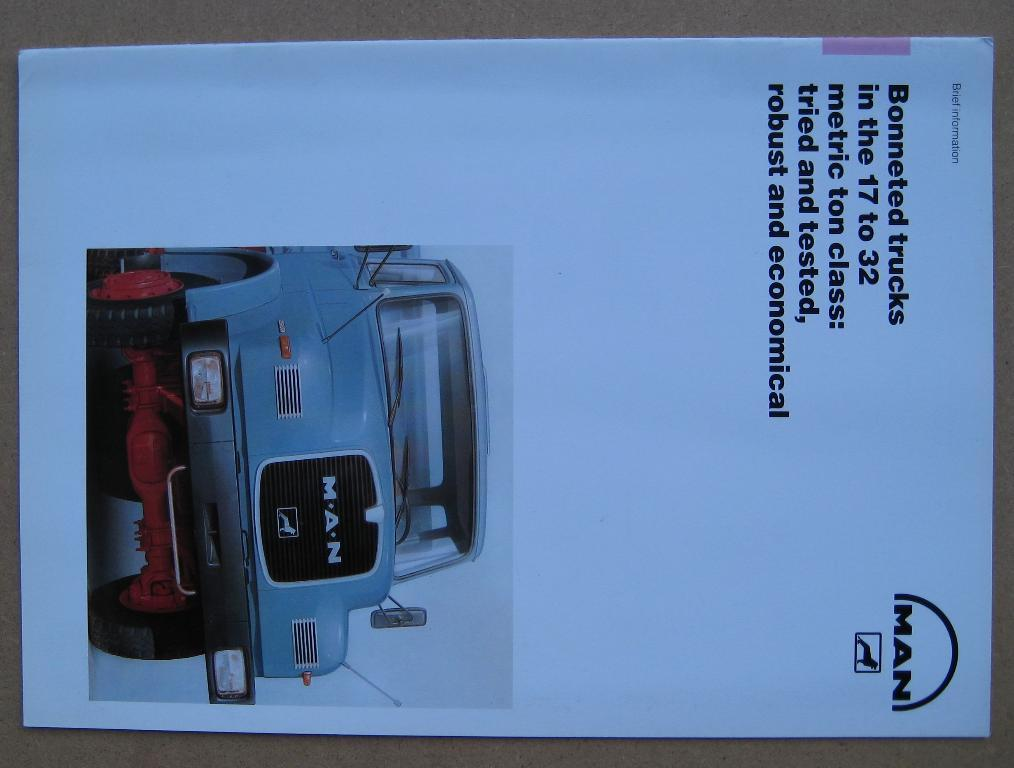What is present in the image that contains both text and an image? There is a poster in the image that contains text and an image. What type of image is on the poster? The poster has an image of a vehicle. Is there a girl sleeping on the poster in the image? There is no girl or any reference to sleep on the poster in the image; it only contains text and an image of a vehicle. 